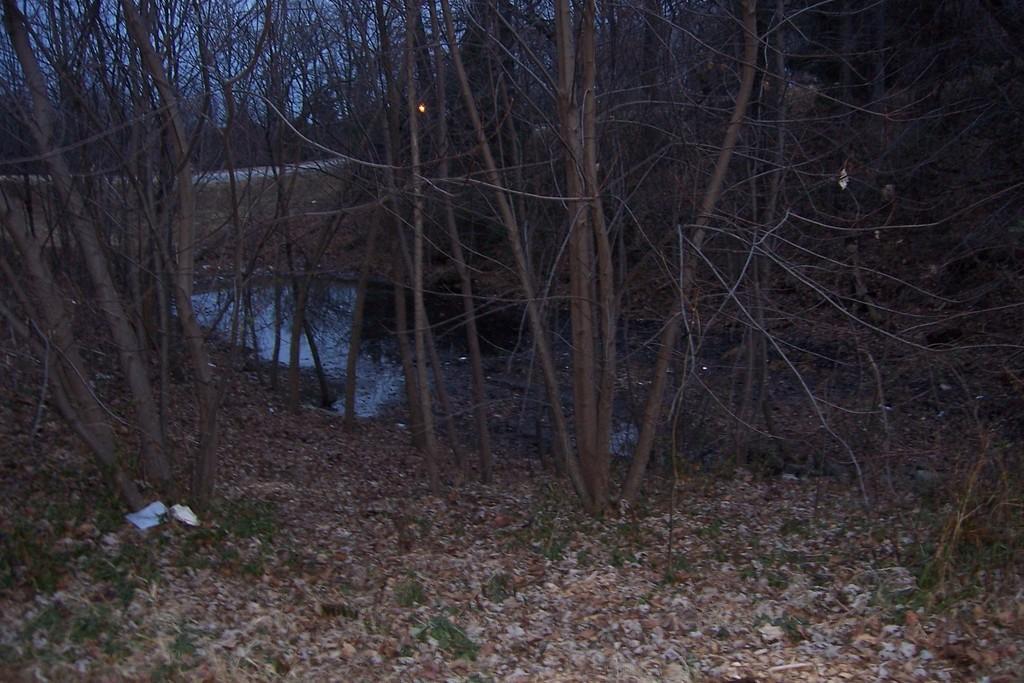How would you summarize this image in a sentence or two? In this image we can see trees, grass, rocks, there is a light, also we can see the lake, and the sky. 